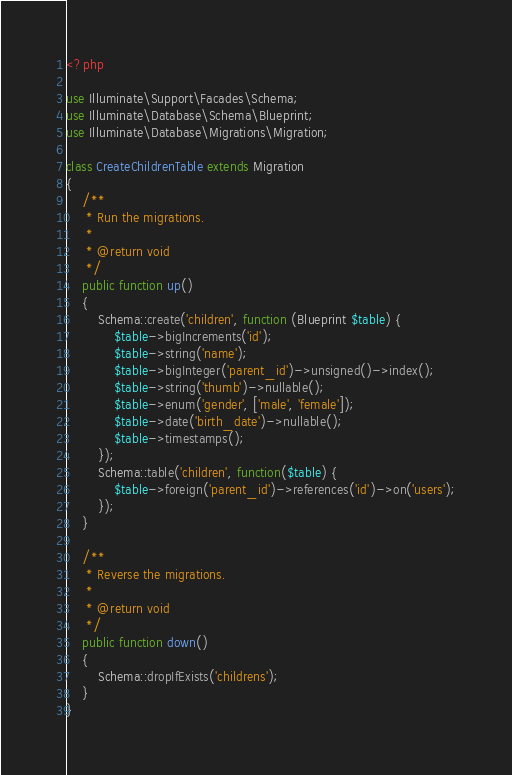Convert code to text. <code><loc_0><loc_0><loc_500><loc_500><_PHP_><?php

use Illuminate\Support\Facades\Schema;
use Illuminate\Database\Schema\Blueprint;
use Illuminate\Database\Migrations\Migration;

class CreateChildrenTable extends Migration
{
    /**
     * Run the migrations.
     *
     * @return void
     */
    public function up()
    {
        Schema::create('children', function (Blueprint $table) {
            $table->bigIncrements('id');
            $table->string('name');
            $table->bigInteger('parent_id')->unsigned()->index();
            $table->string('thumb')->nullable();
            $table->enum('gender', ['male', 'female']);
            $table->date('birth_date')->nullable();
            $table->timestamps();
        });
        Schema::table('children', function($table) {
            $table->foreign('parent_id')->references('id')->on('users');
        });
    }

    /**
     * Reverse the migrations.
     *
     * @return void
     */
    public function down()
    {
        Schema::dropIfExists('childrens');
    }
}
</code> 